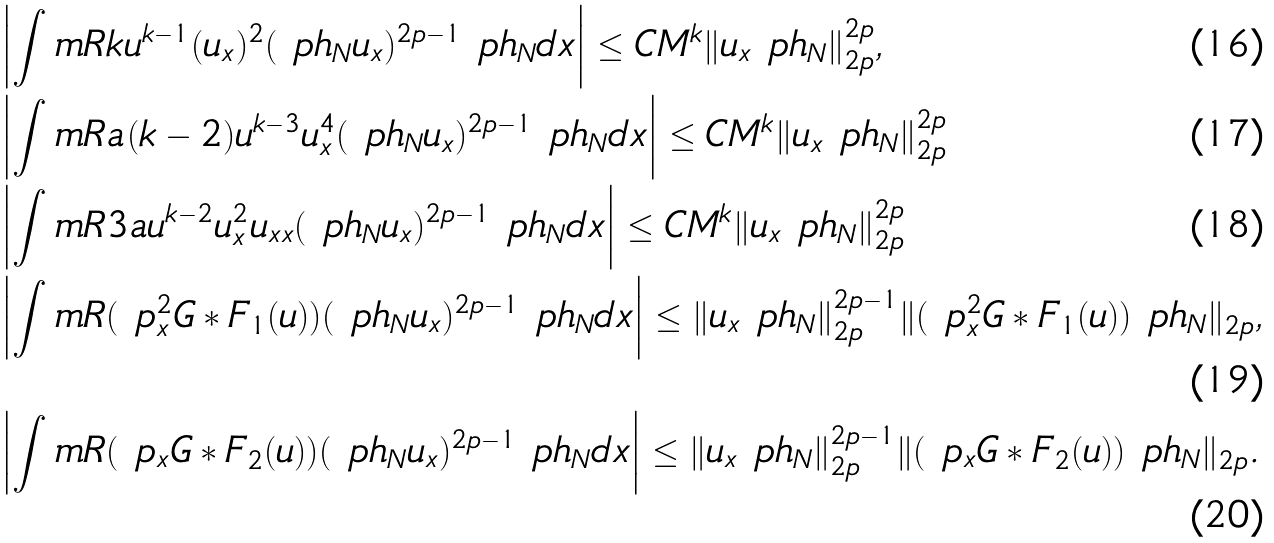<formula> <loc_0><loc_0><loc_500><loc_500>& \left | \int _ { \ } m { R } k u ^ { k - 1 } ( u _ { x } ) ^ { 2 } ( \ p h _ { N } u _ { x } ) ^ { 2 p - 1 } \ p h _ { N } d x \right | \leq C M ^ { k } \| u _ { x } \ p h _ { N } \| _ { 2 p } ^ { 2 p } , \\ & \left | \int _ { \ } m { R } a ( k - 2 ) u ^ { k - 3 } u _ { x } ^ { 4 } ( \ p h _ { N } u _ { x } ) ^ { 2 p - 1 } \ p h _ { N } d x \right | \leq C M ^ { k } \| u _ { x } \ p h _ { N } \| _ { 2 p } ^ { 2 p } \\ & \left | \int _ { \ } m { R } 3 a u ^ { k - 2 } u _ { x } ^ { 2 } u _ { x x } ( \ p h _ { N } u _ { x } ) ^ { 2 p - 1 } \ p h _ { N } d x \right | \leq C M ^ { k } \| u _ { x } \ p h _ { N } \| _ { 2 p } ^ { 2 p } \\ & \left | \int _ { \ } m { R } ( \ p _ { x } ^ { 2 } G * F _ { 1 } ( u ) ) ( \ p h _ { N } u _ { x } ) ^ { 2 p - 1 } \ p h _ { N } d x \right | \leq \| u _ { x } \ p h _ { N } \| _ { 2 p } ^ { 2 p - 1 } \| ( \ p _ { x } ^ { 2 } G * F _ { 1 } ( u ) ) \ p h _ { N } \| _ { 2 p } , \\ & \left | \int _ { \ } m { R } ( \ p _ { x } G * F _ { 2 } ( u ) ) ( \ p h _ { N } u _ { x } ) ^ { 2 p - 1 } \ p h _ { N } d x \right | \leq \| u _ { x } \ p h _ { N } \| _ { 2 p } ^ { 2 p - 1 } \| ( \ p _ { x } G * F _ { 2 } ( u ) ) \ p h _ { N } \| _ { 2 p } .</formula> 